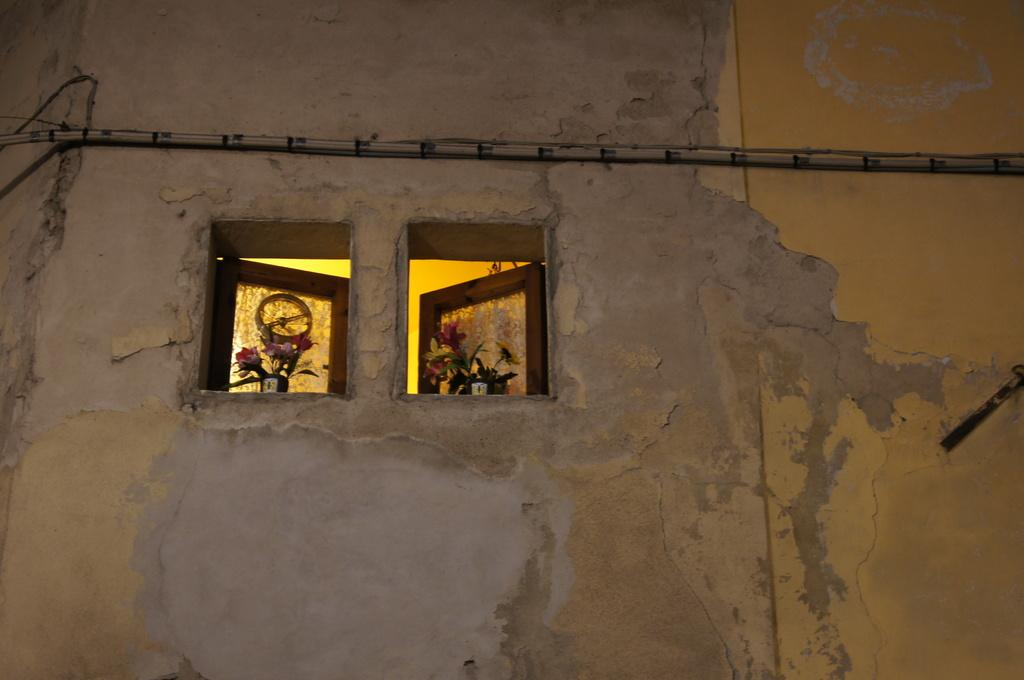What can be seen through the windows in the image? The details about what can be seen through the windows are not provided in the facts. What type of flowers are present in the image? The type of flowers is not specified in the facts. What is the wall made of in the image? The material of the wall is not mentioned in the facts. What is the object attached to the wall in the image? The facts do not specify what the object is. How many chickens are present in the image? There are no chickens present in the image. 